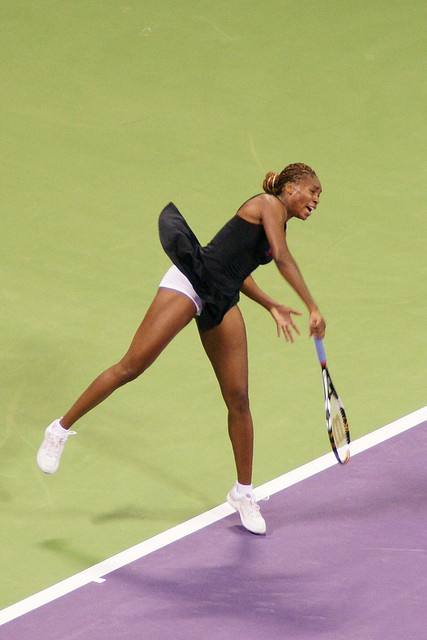Describe the objects in this image and their specific colors. I can see people in olive, black, maroon, salmon, and brown tones and tennis racket in olive, tan, white, and darkgray tones in this image. 